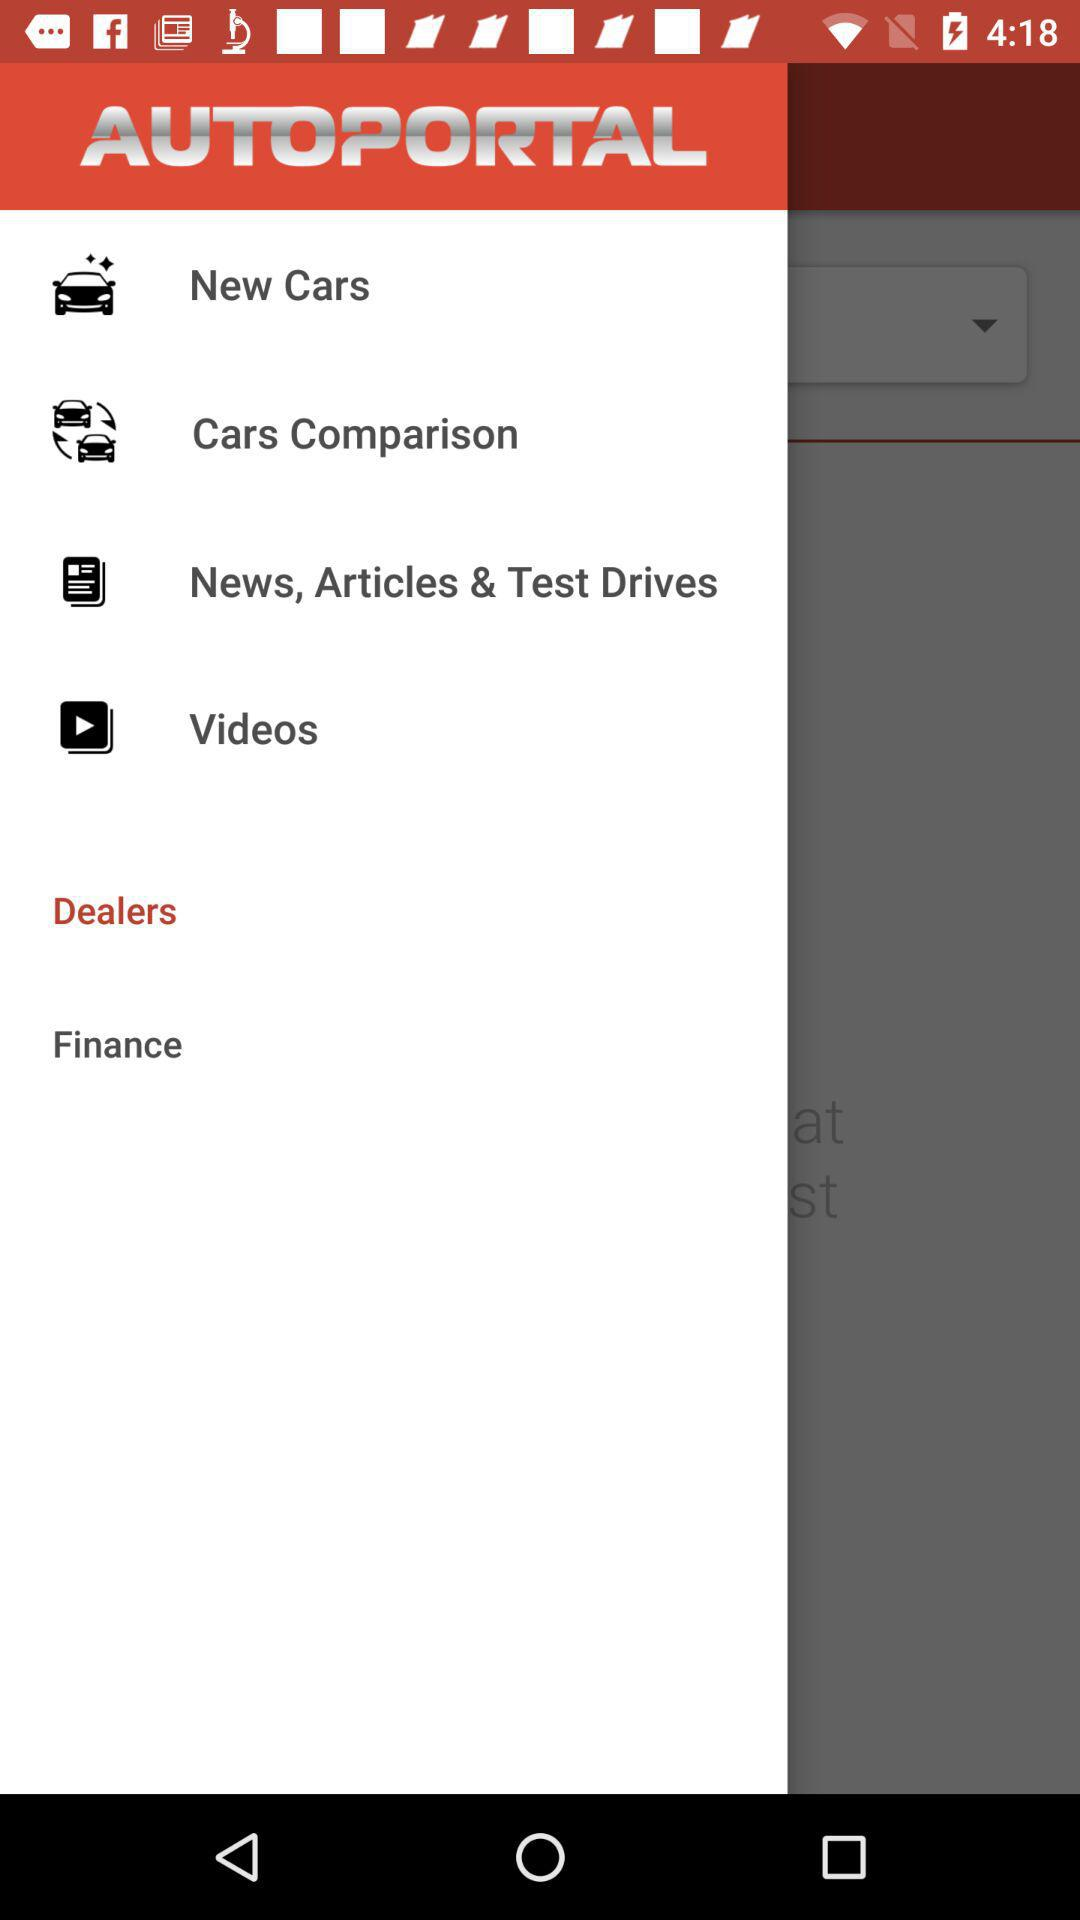What is the application name? The application name is "AUTOPORTAL". 